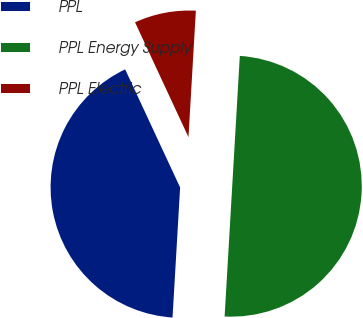Convert chart to OTSL. <chart><loc_0><loc_0><loc_500><loc_500><pie_chart><fcel>PPL<fcel>PPL Energy Supply<fcel>PPL Electric<nl><fcel>42.14%<fcel>50.0%<fcel>7.86%<nl></chart> 